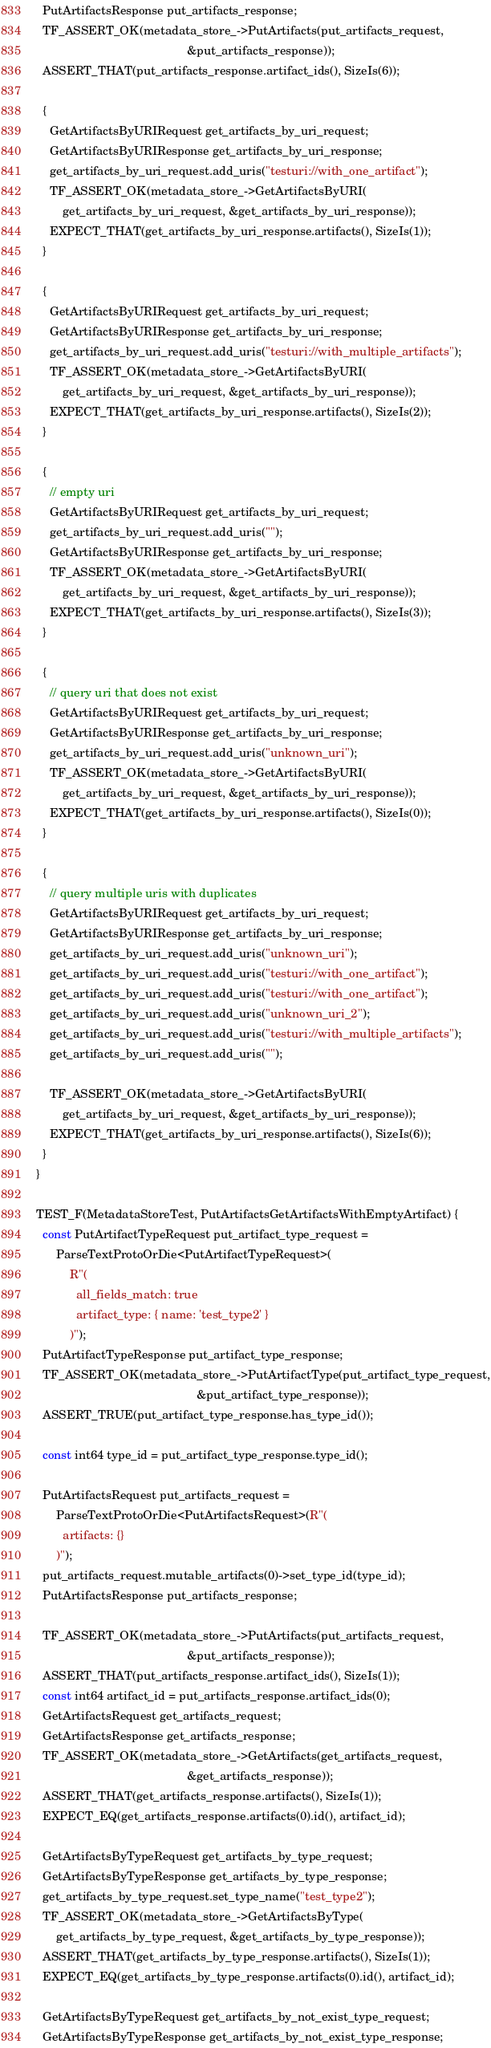Convert code to text. <code><loc_0><loc_0><loc_500><loc_500><_C++_>  PutArtifactsResponse put_artifacts_response;
  TF_ASSERT_OK(metadata_store_->PutArtifacts(put_artifacts_request,
                                             &put_artifacts_response));
  ASSERT_THAT(put_artifacts_response.artifact_ids(), SizeIs(6));

  {
    GetArtifactsByURIRequest get_artifacts_by_uri_request;
    GetArtifactsByURIResponse get_artifacts_by_uri_response;
    get_artifacts_by_uri_request.add_uris("testuri://with_one_artifact");
    TF_ASSERT_OK(metadata_store_->GetArtifactsByURI(
        get_artifacts_by_uri_request, &get_artifacts_by_uri_response));
    EXPECT_THAT(get_artifacts_by_uri_response.artifacts(), SizeIs(1));
  }

  {
    GetArtifactsByURIRequest get_artifacts_by_uri_request;
    GetArtifactsByURIResponse get_artifacts_by_uri_response;
    get_artifacts_by_uri_request.add_uris("testuri://with_multiple_artifacts");
    TF_ASSERT_OK(metadata_store_->GetArtifactsByURI(
        get_artifacts_by_uri_request, &get_artifacts_by_uri_response));
    EXPECT_THAT(get_artifacts_by_uri_response.artifacts(), SizeIs(2));
  }

  {
    // empty uri
    GetArtifactsByURIRequest get_artifacts_by_uri_request;
    get_artifacts_by_uri_request.add_uris("");
    GetArtifactsByURIResponse get_artifacts_by_uri_response;
    TF_ASSERT_OK(metadata_store_->GetArtifactsByURI(
        get_artifacts_by_uri_request, &get_artifacts_by_uri_response));
    EXPECT_THAT(get_artifacts_by_uri_response.artifacts(), SizeIs(3));
  }

  {
    // query uri that does not exist
    GetArtifactsByURIRequest get_artifacts_by_uri_request;
    GetArtifactsByURIResponse get_artifacts_by_uri_response;
    get_artifacts_by_uri_request.add_uris("unknown_uri");
    TF_ASSERT_OK(metadata_store_->GetArtifactsByURI(
        get_artifacts_by_uri_request, &get_artifacts_by_uri_response));
    EXPECT_THAT(get_artifacts_by_uri_response.artifacts(), SizeIs(0));
  }

  {
    // query multiple uris with duplicates
    GetArtifactsByURIRequest get_artifacts_by_uri_request;
    GetArtifactsByURIResponse get_artifacts_by_uri_response;
    get_artifacts_by_uri_request.add_uris("unknown_uri");
    get_artifacts_by_uri_request.add_uris("testuri://with_one_artifact");
    get_artifacts_by_uri_request.add_uris("testuri://with_one_artifact");
    get_artifacts_by_uri_request.add_uris("unknown_uri_2");
    get_artifacts_by_uri_request.add_uris("testuri://with_multiple_artifacts");
    get_artifacts_by_uri_request.add_uris("");

    TF_ASSERT_OK(metadata_store_->GetArtifactsByURI(
        get_artifacts_by_uri_request, &get_artifacts_by_uri_response));
    EXPECT_THAT(get_artifacts_by_uri_response.artifacts(), SizeIs(6));
  }
}

TEST_F(MetadataStoreTest, PutArtifactsGetArtifactsWithEmptyArtifact) {
  const PutArtifactTypeRequest put_artifact_type_request =
      ParseTextProtoOrDie<PutArtifactTypeRequest>(
          R"(
            all_fields_match: true
            artifact_type: { name: 'test_type2' }
          )");
  PutArtifactTypeResponse put_artifact_type_response;
  TF_ASSERT_OK(metadata_store_->PutArtifactType(put_artifact_type_request,
                                                &put_artifact_type_response));
  ASSERT_TRUE(put_artifact_type_response.has_type_id());

  const int64 type_id = put_artifact_type_response.type_id();

  PutArtifactsRequest put_artifacts_request =
      ParseTextProtoOrDie<PutArtifactsRequest>(R"(
        artifacts: {}
      )");
  put_artifacts_request.mutable_artifacts(0)->set_type_id(type_id);
  PutArtifactsResponse put_artifacts_response;

  TF_ASSERT_OK(metadata_store_->PutArtifacts(put_artifacts_request,
                                             &put_artifacts_response));
  ASSERT_THAT(put_artifacts_response.artifact_ids(), SizeIs(1));
  const int64 artifact_id = put_artifacts_response.artifact_ids(0);
  GetArtifactsRequest get_artifacts_request;
  GetArtifactsResponse get_artifacts_response;
  TF_ASSERT_OK(metadata_store_->GetArtifacts(get_artifacts_request,
                                             &get_artifacts_response));
  ASSERT_THAT(get_artifacts_response.artifacts(), SizeIs(1));
  EXPECT_EQ(get_artifacts_response.artifacts(0).id(), artifact_id);

  GetArtifactsByTypeRequest get_artifacts_by_type_request;
  GetArtifactsByTypeResponse get_artifacts_by_type_response;
  get_artifacts_by_type_request.set_type_name("test_type2");
  TF_ASSERT_OK(metadata_store_->GetArtifactsByType(
      get_artifacts_by_type_request, &get_artifacts_by_type_response));
  ASSERT_THAT(get_artifacts_by_type_response.artifacts(), SizeIs(1));
  EXPECT_EQ(get_artifacts_by_type_response.artifacts(0).id(), artifact_id);

  GetArtifactsByTypeRequest get_artifacts_by_not_exist_type_request;
  GetArtifactsByTypeResponse get_artifacts_by_not_exist_type_response;</code> 